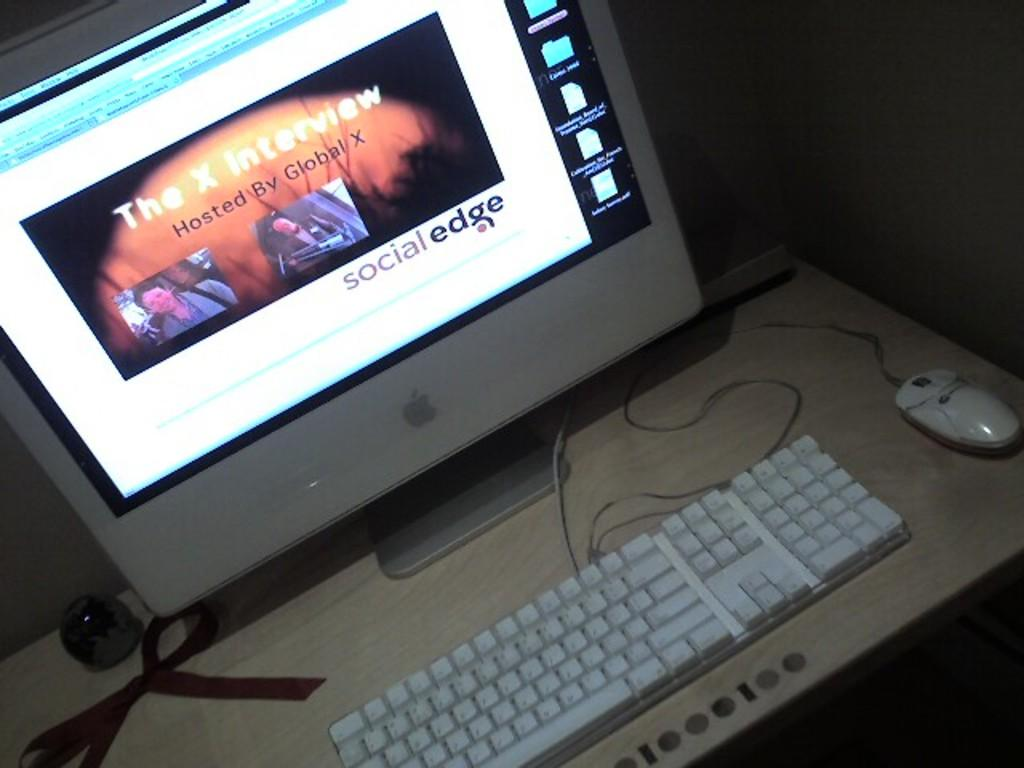<image>
Write a terse but informative summary of the picture. an apple computer with the screen saying 'the x interview' on it 